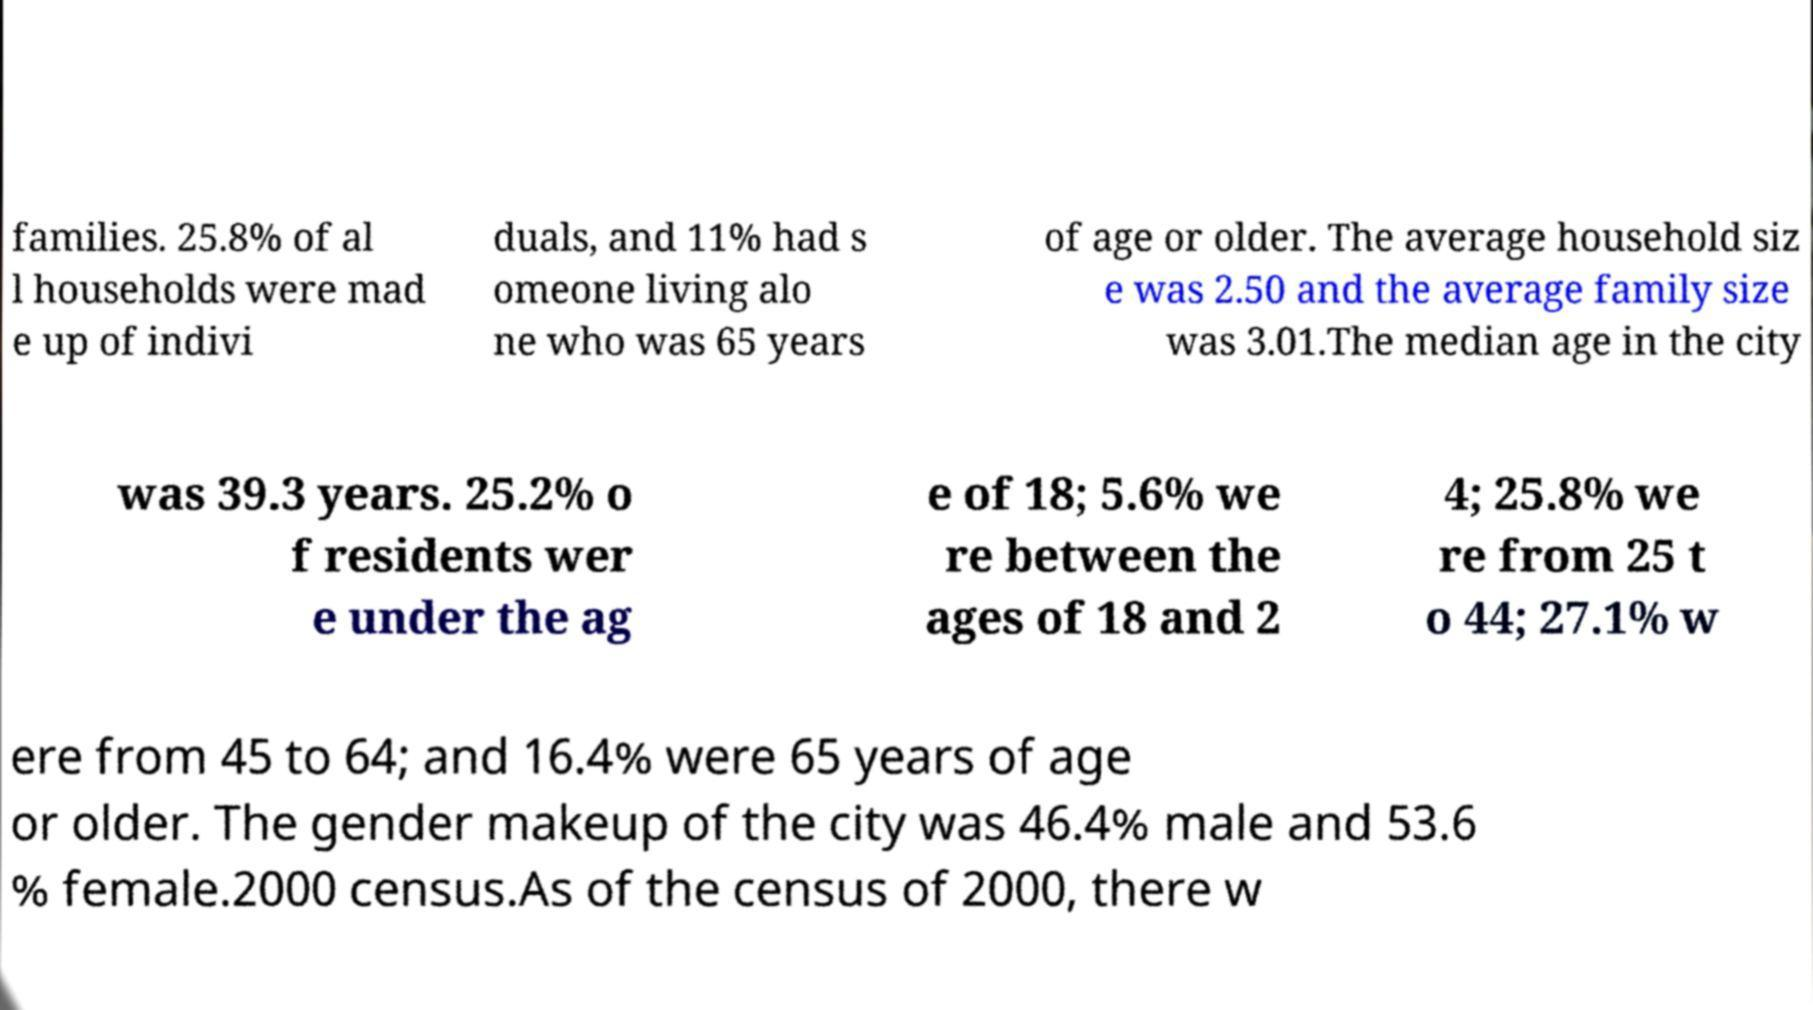Could you assist in decoding the text presented in this image and type it out clearly? families. 25.8% of al l households were mad e up of indivi duals, and 11% had s omeone living alo ne who was 65 years of age or older. The average household siz e was 2.50 and the average family size was 3.01.The median age in the city was 39.3 years. 25.2% o f residents wer e under the ag e of 18; 5.6% we re between the ages of 18 and 2 4; 25.8% we re from 25 t o 44; 27.1% w ere from 45 to 64; and 16.4% were 65 years of age or older. The gender makeup of the city was 46.4% male and 53.6 % female.2000 census.As of the census of 2000, there w 